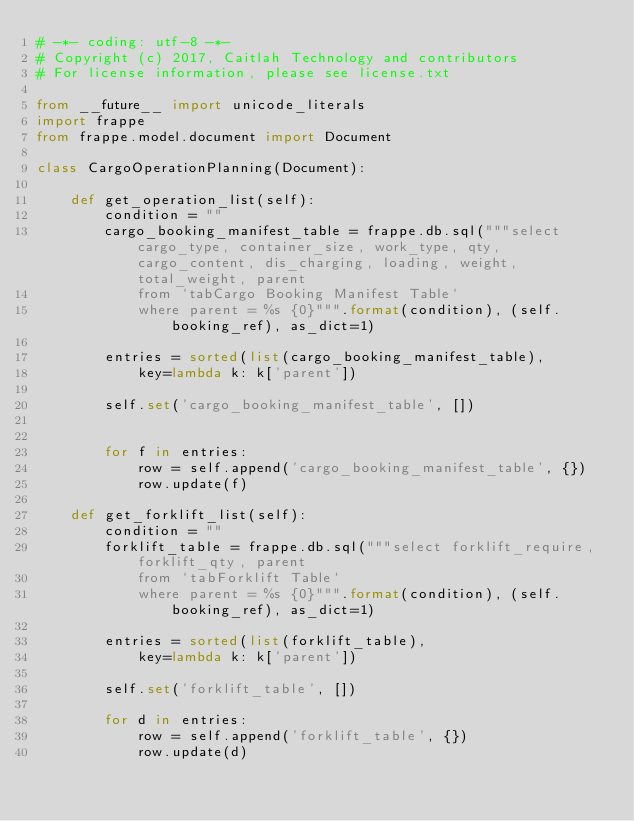Convert code to text. <code><loc_0><loc_0><loc_500><loc_500><_Python_># -*- coding: utf-8 -*-
# Copyright (c) 2017, Caitlah Technology and contributors
# For license information, please see license.txt

from __future__ import unicode_literals
import frappe
from frappe.model.document import Document

class CargoOperationPlanning(Document):

	def get_operation_list(self):
		condition = ""
		cargo_booking_manifest_table = frappe.db.sql("""select cargo_type, container_size, work_type, qty, cargo_content, dis_charging, loading, weight, total_weight, parent
			from `tabCargo Booking Manifest Table`
			where parent = %s {0}""".format(condition), (self.booking_ref), as_dict=1)

		entries = sorted(list(cargo_booking_manifest_table),
			key=lambda k: k['parent'])

		self.set('cargo_booking_manifest_table', [])


		for f in entries:
			row = self.append('cargo_booking_manifest_table', {})
			row.update(f)

	def get_forklift_list(self):
		condition = ""
		forklift_table = frappe.db.sql("""select forklift_require, forklift_qty, parent
			from `tabForklift Table`
			where parent = %s {0}""".format(condition), (self.booking_ref), as_dict=1)

		entries = sorted(list(forklift_table),
			key=lambda k: k['parent'])

		self.set('forklift_table', [])

		for d in entries:
			row = self.append('forklift_table', {})
			row.update(d)
</code> 